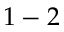Convert formula to latex. <formula><loc_0><loc_0><loc_500><loc_500>1 - 2</formula> 